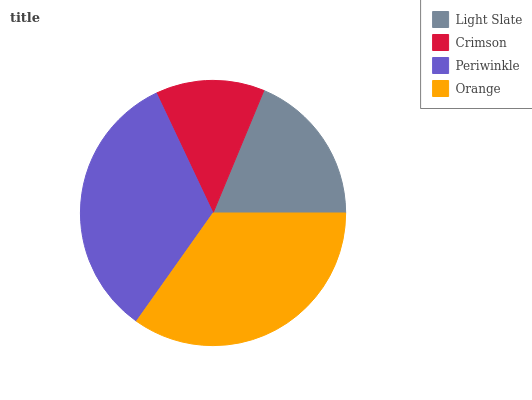Is Crimson the minimum?
Answer yes or no. Yes. Is Orange the maximum?
Answer yes or no. Yes. Is Periwinkle the minimum?
Answer yes or no. No. Is Periwinkle the maximum?
Answer yes or no. No. Is Periwinkle greater than Crimson?
Answer yes or no. Yes. Is Crimson less than Periwinkle?
Answer yes or no. Yes. Is Crimson greater than Periwinkle?
Answer yes or no. No. Is Periwinkle less than Crimson?
Answer yes or no. No. Is Periwinkle the high median?
Answer yes or no. Yes. Is Light Slate the low median?
Answer yes or no. Yes. Is Orange the high median?
Answer yes or no. No. Is Crimson the low median?
Answer yes or no. No. 